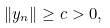<formula> <loc_0><loc_0><loc_500><loc_500>\| y _ { n } \| \geq c > 0 ,</formula> 